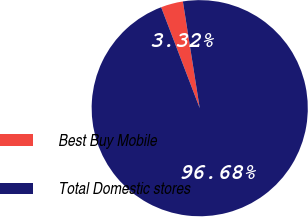Convert chart to OTSL. <chart><loc_0><loc_0><loc_500><loc_500><pie_chart><fcel>Best Buy Mobile<fcel>Total Domestic stores<nl><fcel>3.32%<fcel>96.68%<nl></chart> 